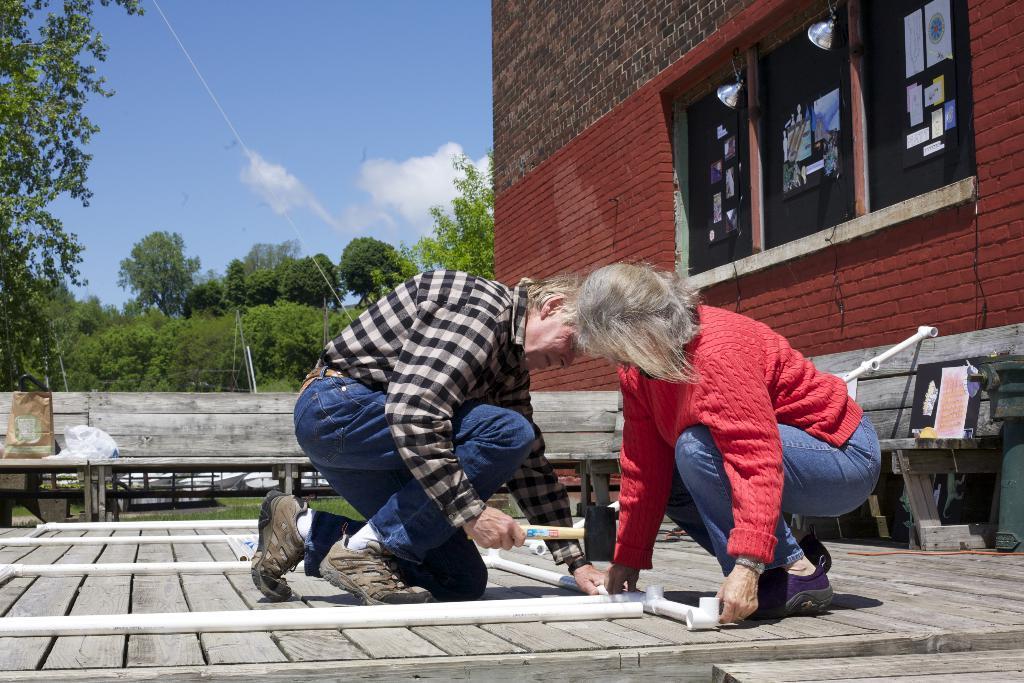Please provide a concise description of this image. In this image we can see an old man wearing shirt, shoes and socks is holding a hammer and women wearing t-shirt and shoes are on the wooden surface. Here we can see pipes, you can see wooden benches, brick wall, windows, lights, trees and the clouds the sky with clouds in the background. 